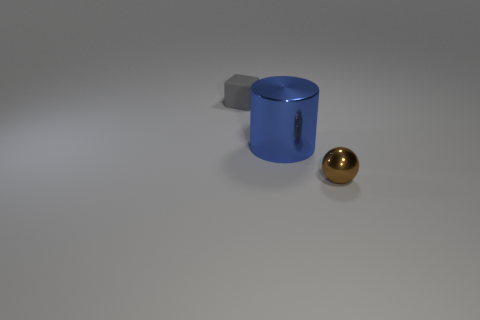Add 1 brown metal spheres. How many objects exist? 4 Subtract all balls. How many objects are left? 2 Add 2 tiny purple objects. How many tiny purple objects exist? 2 Subtract 0 cyan cylinders. How many objects are left? 3 Subtract all large blue matte blocks. Subtract all blue cylinders. How many objects are left? 2 Add 1 shiny balls. How many shiny balls are left? 2 